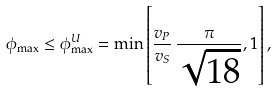Convert formula to latex. <formula><loc_0><loc_0><loc_500><loc_500>\phi _ { \max } \leq \phi _ { \max } ^ { U } = \min \left [ \frac { v _ { P } } { v _ { S } } \, \frac { \pi } { \sqrt { 1 8 } } , 1 \right ] ,</formula> 